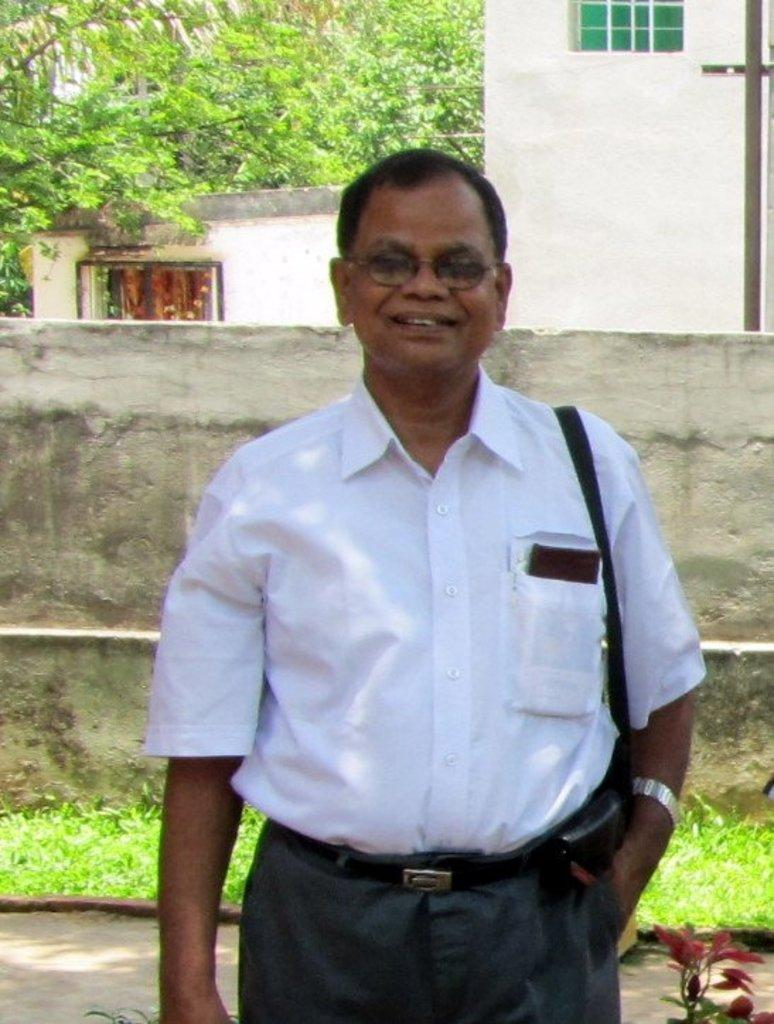Who or what is present in the image? There is a person in the image. What is the person wearing? The person is wearing a white shirt. What is the person's facial expression? The person is smiling. What can be seen in the background of the image? There is a building and a wall visible behind the person. What type of ship can be seen in the person's pocket in the image? There is no ship visible in the image, and the person's pocket is not mentioned in the provided facts. 